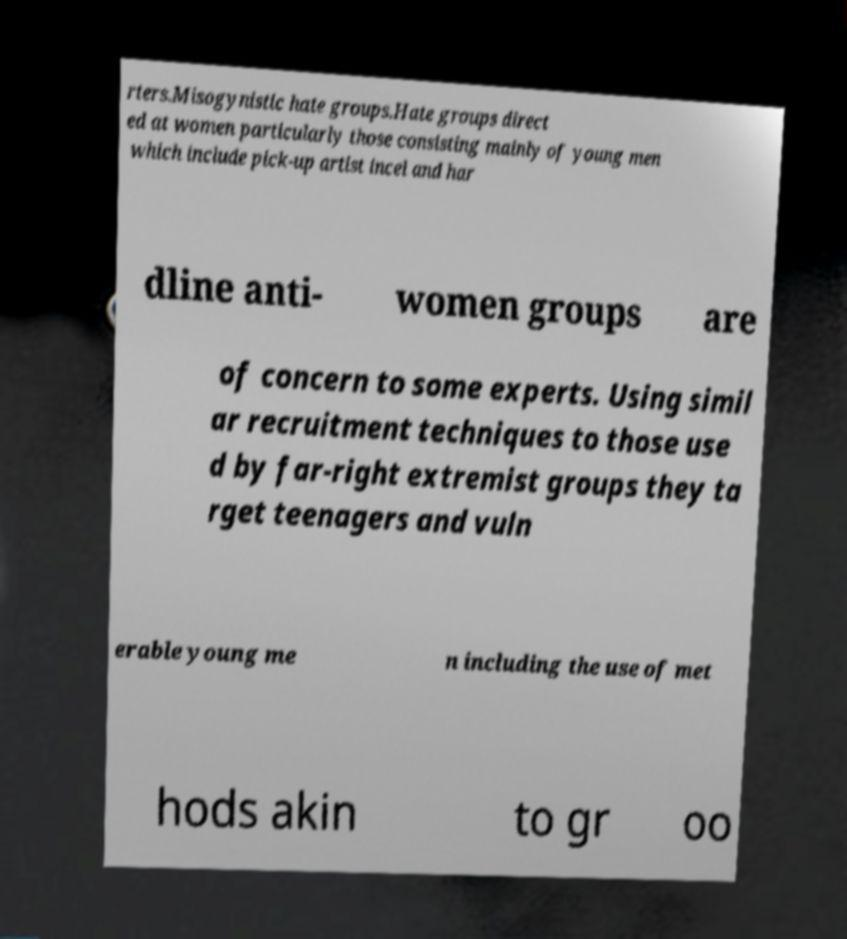Can you accurately transcribe the text from the provided image for me? rters.Misogynistic hate groups.Hate groups direct ed at women particularly those consisting mainly of young men which include pick-up artist incel and har dline anti- women groups are of concern to some experts. Using simil ar recruitment techniques to those use d by far-right extremist groups they ta rget teenagers and vuln erable young me n including the use of met hods akin to gr oo 